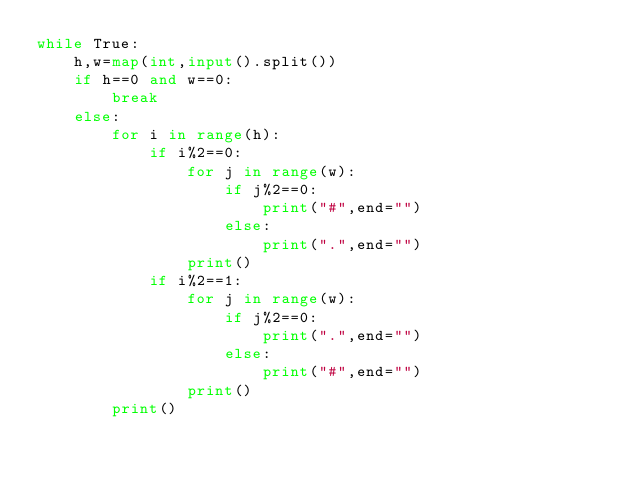Convert code to text. <code><loc_0><loc_0><loc_500><loc_500><_Python_>while True:
    h,w=map(int,input().split())
    if h==0 and w==0:
        break
    else:
        for i in range(h):
            if i%2==0:
                for j in range(w):
                    if j%2==0:
                        print("#",end="")
                    else:
                        print(".",end="")
                print()
            if i%2==1:
                for j in range(w):
                    if j%2==0:
                        print(".",end="")
                    else:
                        print("#",end="")
                print()
        print()
</code> 